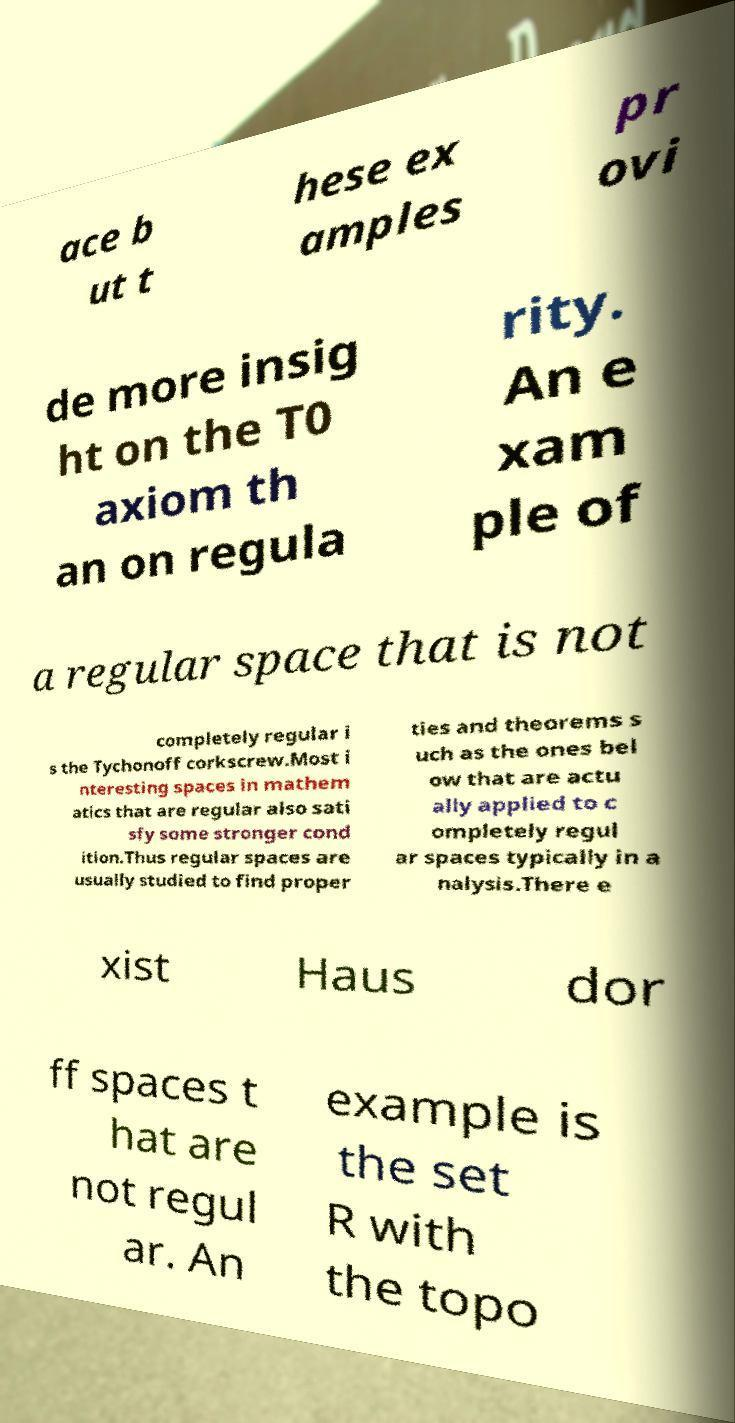Please identify and transcribe the text found in this image. ace b ut t hese ex amples pr ovi de more insig ht on the T0 axiom th an on regula rity. An e xam ple of a regular space that is not completely regular i s the Tychonoff corkscrew.Most i nteresting spaces in mathem atics that are regular also sati sfy some stronger cond ition.Thus regular spaces are usually studied to find proper ties and theorems s uch as the ones bel ow that are actu ally applied to c ompletely regul ar spaces typically in a nalysis.There e xist Haus dor ff spaces t hat are not regul ar. An example is the set R with the topo 